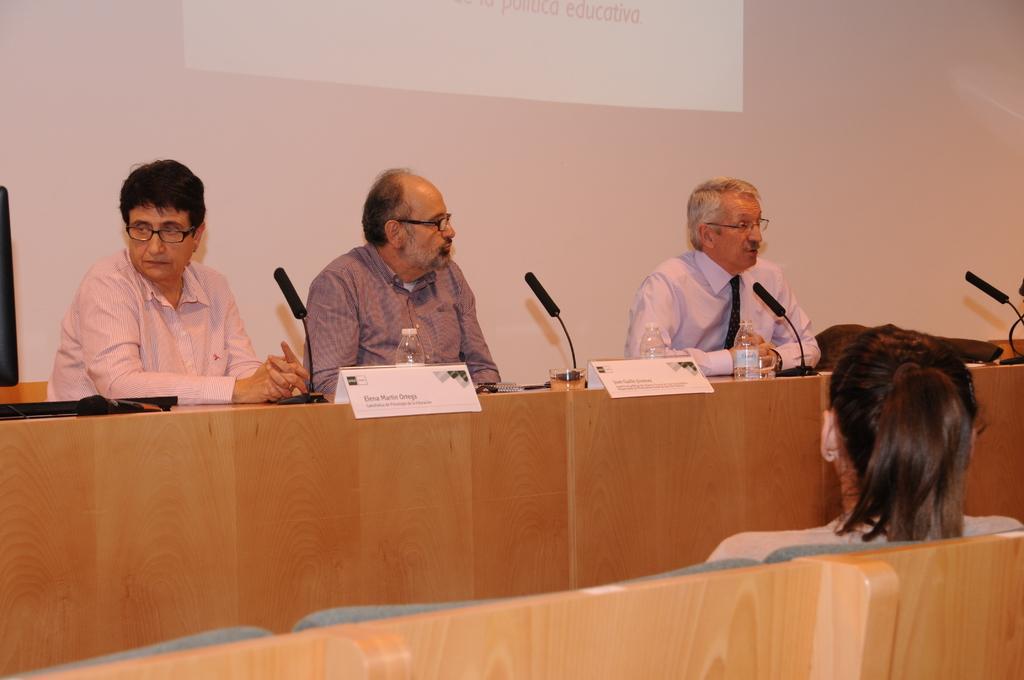How would you summarize this image in a sentence or two? In this image I can see in the middle two persons are there, they wear shirts, spectacles. On the right side a man is speaking in the microphone and hear a person is sitting on the chair and looking at him. At the top it is the projector screen. 